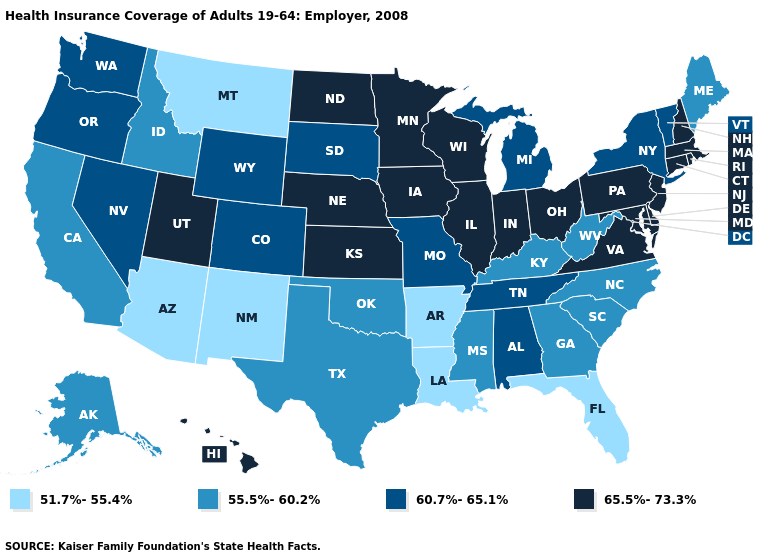Name the states that have a value in the range 60.7%-65.1%?
Keep it brief. Alabama, Colorado, Michigan, Missouri, Nevada, New York, Oregon, South Dakota, Tennessee, Vermont, Washington, Wyoming. Name the states that have a value in the range 51.7%-55.4%?
Quick response, please. Arizona, Arkansas, Florida, Louisiana, Montana, New Mexico. Name the states that have a value in the range 60.7%-65.1%?
Give a very brief answer. Alabama, Colorado, Michigan, Missouri, Nevada, New York, Oregon, South Dakota, Tennessee, Vermont, Washington, Wyoming. Among the states that border Kentucky , does Illinois have the highest value?
Give a very brief answer. Yes. Does the first symbol in the legend represent the smallest category?
Keep it brief. Yes. Which states hav the highest value in the Northeast?
Concise answer only. Connecticut, Massachusetts, New Hampshire, New Jersey, Pennsylvania, Rhode Island. Name the states that have a value in the range 60.7%-65.1%?
Write a very short answer. Alabama, Colorado, Michigan, Missouri, Nevada, New York, Oregon, South Dakota, Tennessee, Vermont, Washington, Wyoming. What is the lowest value in states that border Kansas?
Answer briefly. 55.5%-60.2%. Among the states that border Tennessee , does Georgia have the lowest value?
Give a very brief answer. No. Name the states that have a value in the range 55.5%-60.2%?
Quick response, please. Alaska, California, Georgia, Idaho, Kentucky, Maine, Mississippi, North Carolina, Oklahoma, South Carolina, Texas, West Virginia. Which states have the lowest value in the USA?
Quick response, please. Arizona, Arkansas, Florida, Louisiana, Montana, New Mexico. What is the value of Vermont?
Write a very short answer. 60.7%-65.1%. Name the states that have a value in the range 60.7%-65.1%?
Answer briefly. Alabama, Colorado, Michigan, Missouri, Nevada, New York, Oregon, South Dakota, Tennessee, Vermont, Washington, Wyoming. Among the states that border Illinois , does Iowa have the lowest value?
Be succinct. No. Which states have the highest value in the USA?
Write a very short answer. Connecticut, Delaware, Hawaii, Illinois, Indiana, Iowa, Kansas, Maryland, Massachusetts, Minnesota, Nebraska, New Hampshire, New Jersey, North Dakota, Ohio, Pennsylvania, Rhode Island, Utah, Virginia, Wisconsin. 